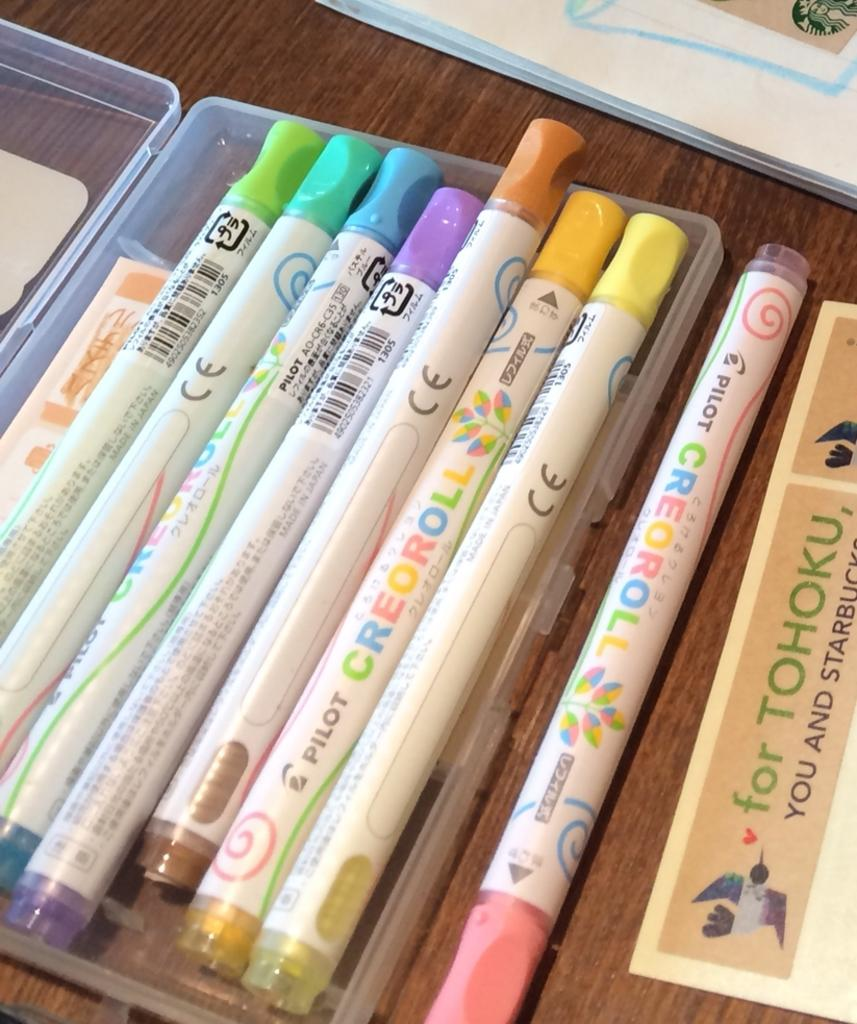What piece of furniture is present in the image? There is a table in the image. What items related to drawing can be seen on the table? There are sketch pens on the table, and they are in a box. What else is on the table besides the sketch pens? There is a book and a paper on the table. What type of car is parked next to the table in the image? There is no car present in the image; it only features a table with sketch pens, a book, and a paper. 